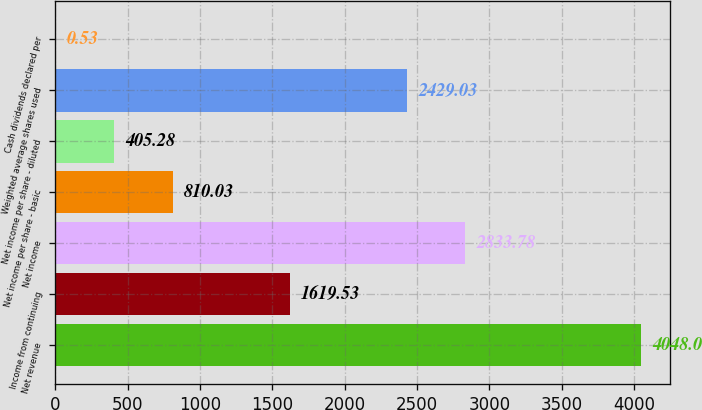Convert chart to OTSL. <chart><loc_0><loc_0><loc_500><loc_500><bar_chart><fcel>Net revenue<fcel>Income from continuing<fcel>Net income<fcel>Net income per share - basic<fcel>Net income per share - diluted<fcel>Weighted average shares used<fcel>Cash dividends declared per<nl><fcel>4048<fcel>1619.53<fcel>2833.78<fcel>810.03<fcel>405.28<fcel>2429.03<fcel>0.53<nl></chart> 